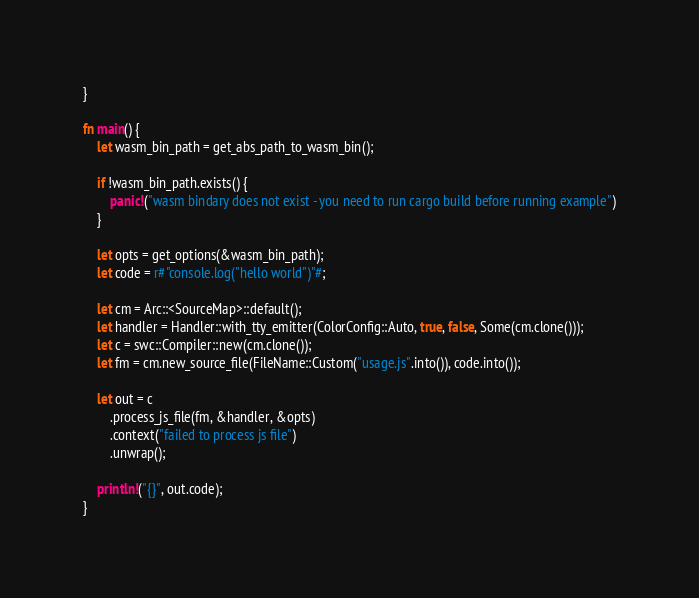Convert code to text. <code><loc_0><loc_0><loc_500><loc_500><_Rust_>}

fn main() {
    let wasm_bin_path = get_abs_path_to_wasm_bin();

    if !wasm_bin_path.exists() {
        panic!("wasm bindary does not exist - you need to run cargo build before running example")
    }

    let opts = get_options(&wasm_bin_path);
    let code = r#"console.log("hello world")"#;

    let cm = Arc::<SourceMap>::default();
    let handler = Handler::with_tty_emitter(ColorConfig::Auto, true, false, Some(cm.clone()));
    let c = swc::Compiler::new(cm.clone());
    let fm = cm.new_source_file(FileName::Custom("usage.js".into()), code.into());

    let out = c
        .process_js_file(fm, &handler, &opts)
        .context("failed to process js file")
        .unwrap();

    println!("{}", out.code);
}</code> 